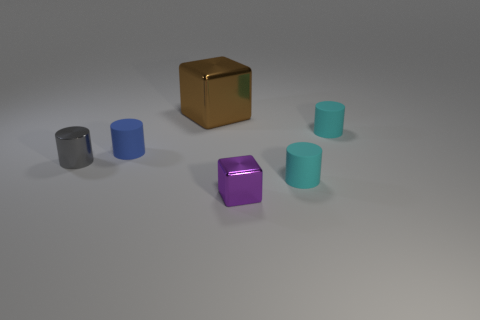Imagine these objects are part of a game. What could be the rules based on their arrangement? If this were a game, one could imagine a rule where the objective is to stack the cylinders in order of size or color, using the reflective brown cube as a base. Another possibility might be a memory game where the position of the objects changes, and the player has to recall the previous arrangement. 